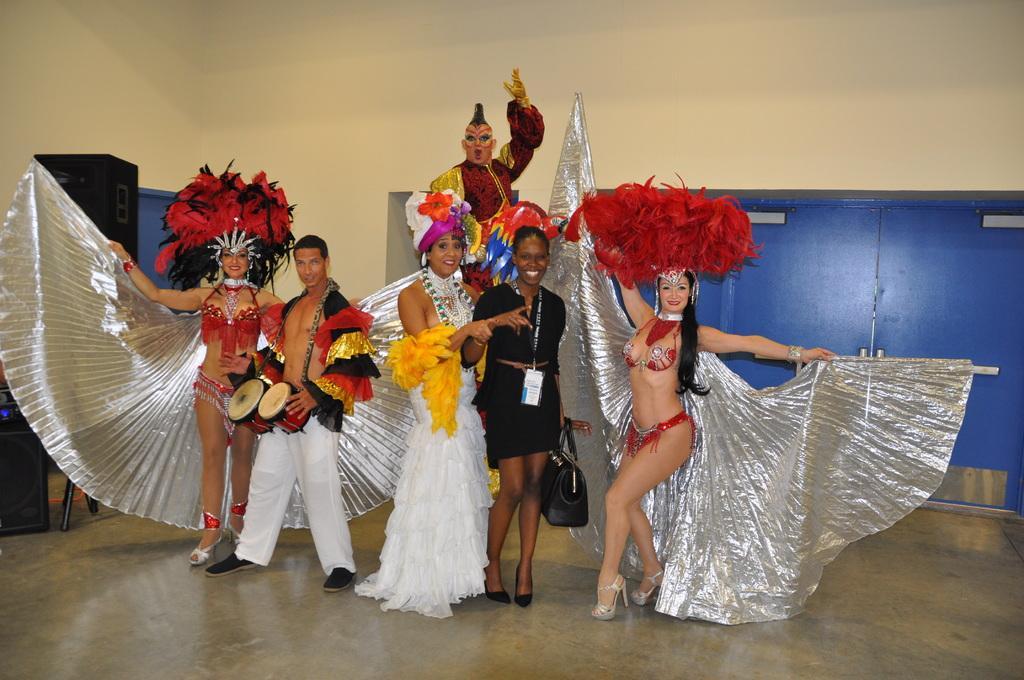Could you give a brief overview of what you see in this image? In this image I can see few people are standing and wearing costumes. I can also see smile on their faces. Here I can see he is is holding a musical instrument. 